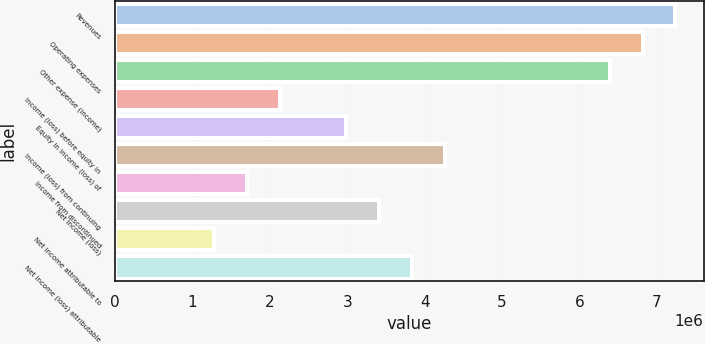Convert chart. <chart><loc_0><loc_0><loc_500><loc_500><bar_chart><fcel>Revenues<fcel>Operating expenses<fcel>Other expense (income)<fcel>Income (loss) before equity in<fcel>Equity in income (loss) of<fcel>Income (loss) from continuing<fcel>Income from discontinued<fcel>Net income (loss)<fcel>Net income attributable to<fcel>Net income (loss) attributable<nl><fcel>7.24198e+06<fcel>6.81598e+06<fcel>6.38998e+06<fcel>2.13e+06<fcel>2.98199e+06<fcel>4.25999e+06<fcel>1.704e+06<fcel>3.40799e+06<fcel>1.278e+06<fcel>3.83399e+06<nl></chart> 